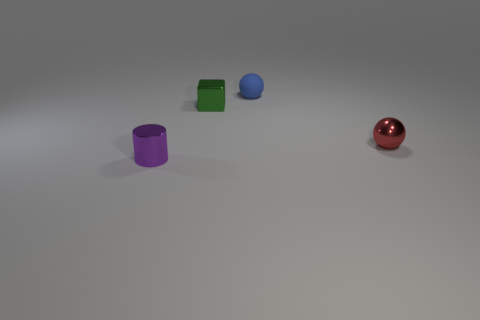Add 3 green metallic blocks. How many objects exist? 7 Subtract all cubes. How many objects are left? 3 Add 1 big blue cylinders. How many big blue cylinders exist? 1 Subtract 0 yellow blocks. How many objects are left? 4 Subtract all blue metal objects. Subtract all metallic cubes. How many objects are left? 3 Add 3 tiny purple things. How many tiny purple things are left? 4 